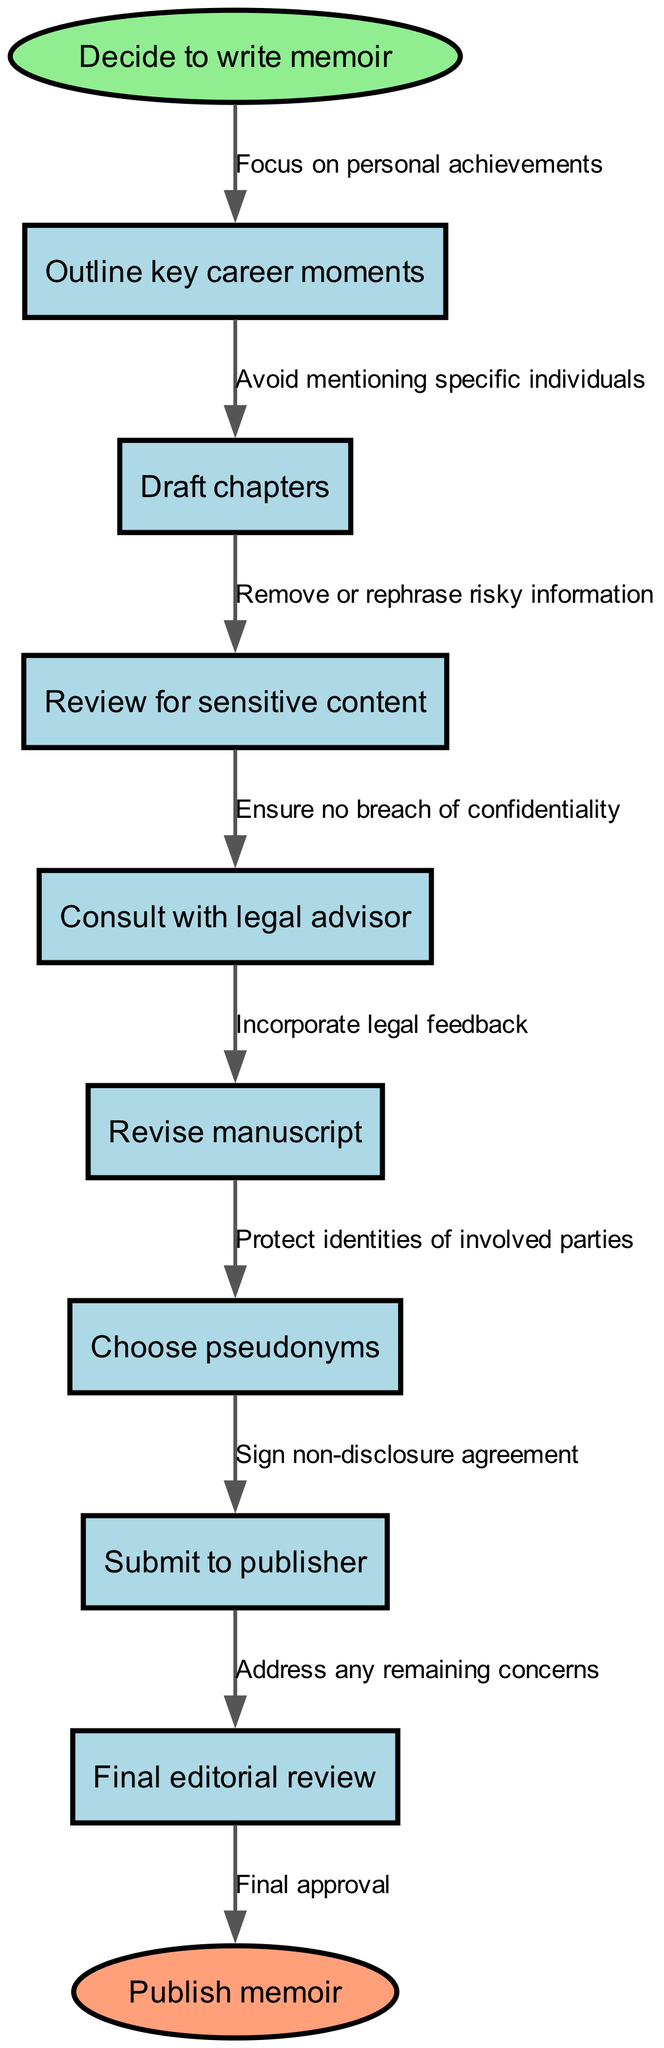What is the starting point of the process? The diagram indicates that the process begins with the decision to write a memoir, which is stated in the "start" node.
Answer: Decide to write memoir How many process steps are there in total? By counting the nodes in the "process" list presented in the diagram, there are a total of eight distinct steps involved in the memoir writing process.
Answer: 8 Which node focuses on legal considerations? The node "Consult with legal advisor" specifically deals with legal aspects of writing the memoir, ensuring no breach of confidentiality.
Answer: Consult with legal advisor What happens after the "Submit to publisher" node? The flow chart indicates that the next step after submitting to the publisher is a final editorial review, as shown by the connecting edge.
Answer: Final editorial review What is the purpose of using pseudonyms? The diagram points out that choosing pseudonyms serves the purpose of protecting the identities of individuals involved in the memoir, as described in the relevant node.
Answer: Protect identities of involved parties What action is taken after reviewing for sensitive content? According to the flow of the diagram, after reviewing for sensitive content, the next action is to consult with a legal advisor to ensure compliance with confidentiality.
Answer: Consult with legal advisor How does one ensure the manuscript is safe to publish? The diagram illustrates that revising the manuscript based on feedback from a legal advisor is crucial for ensuring the manuscript is safe, addressing any sensitive content.
Answer: Incorporate legal feedback How many edges are connected to the “Revise manuscript” node? The “Revise manuscript” node has only one connecting edge that leads to it from the “Consult with legal advisor” node, representing a direct pathway to this step.
Answer: 1 edge What is the last step before publication? The final step before reaching the "Publish memoir" node is the "Final editorial review," which ensures that all concerns are addressed.
Answer: Final editorial review 